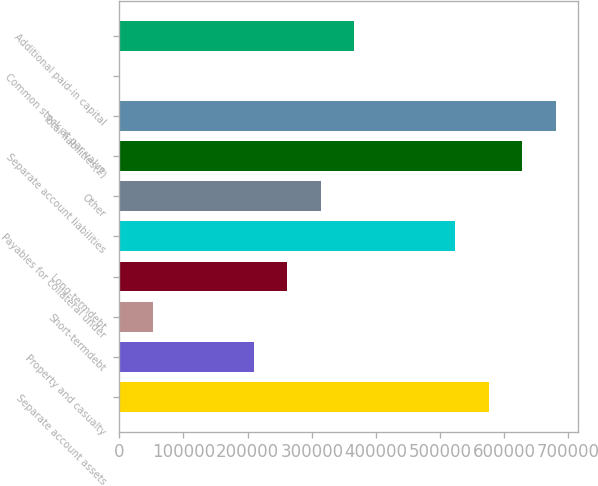<chart> <loc_0><loc_0><loc_500><loc_500><bar_chart><fcel>Separate account assets<fcel>Property and casualty<fcel>Short-termdebt<fcel>Long-termdebt<fcel>Payables for collateral under<fcel>Other<fcel>Separate account liabilities<fcel>Total liabilities(2)<fcel>Common stock at par value<fcel>Additional paid-in capital<nl><fcel>575720<fcel>209358<fcel>52345.5<fcel>261696<fcel>523383<fcel>314033<fcel>628058<fcel>680396<fcel>8<fcel>366370<nl></chart> 